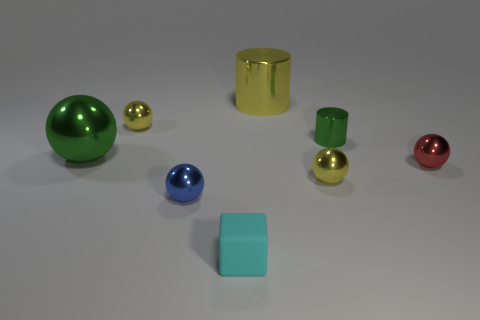There is a large thing that is the same shape as the small blue metallic thing; what is its material?
Your answer should be very brief. Metal. Are there any tiny green objects made of the same material as the cyan block?
Provide a succinct answer. No. There is a small yellow sphere that is behind the yellow object in front of the red thing; are there any tiny things to the right of it?
Ensure brevity in your answer.  Yes. What is the shape of the red thing that is the same size as the block?
Ensure brevity in your answer.  Sphere. There is a yellow shiny sphere on the left side of the blue ball; is it the same size as the yellow ball that is in front of the small red metallic sphere?
Ensure brevity in your answer.  Yes. How many big purple cubes are there?
Offer a terse response. 0. There is a metal cylinder that is behind the metal cylinder in front of the big thing that is to the right of the rubber cube; what size is it?
Make the answer very short. Large. Is the small shiny cylinder the same color as the large ball?
Your response must be concise. Yes. Is there any other thing that has the same size as the blue sphere?
Give a very brief answer. Yes. How many metal objects are left of the small block?
Offer a very short reply. 3. 